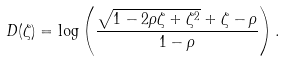<formula> <loc_0><loc_0><loc_500><loc_500>D ( \zeta ) = \log \left ( { \frac { { \sqrt { 1 - 2 \rho \zeta + \zeta ^ { 2 } } } + \zeta - \rho } { 1 - \rho } } \right ) .</formula> 